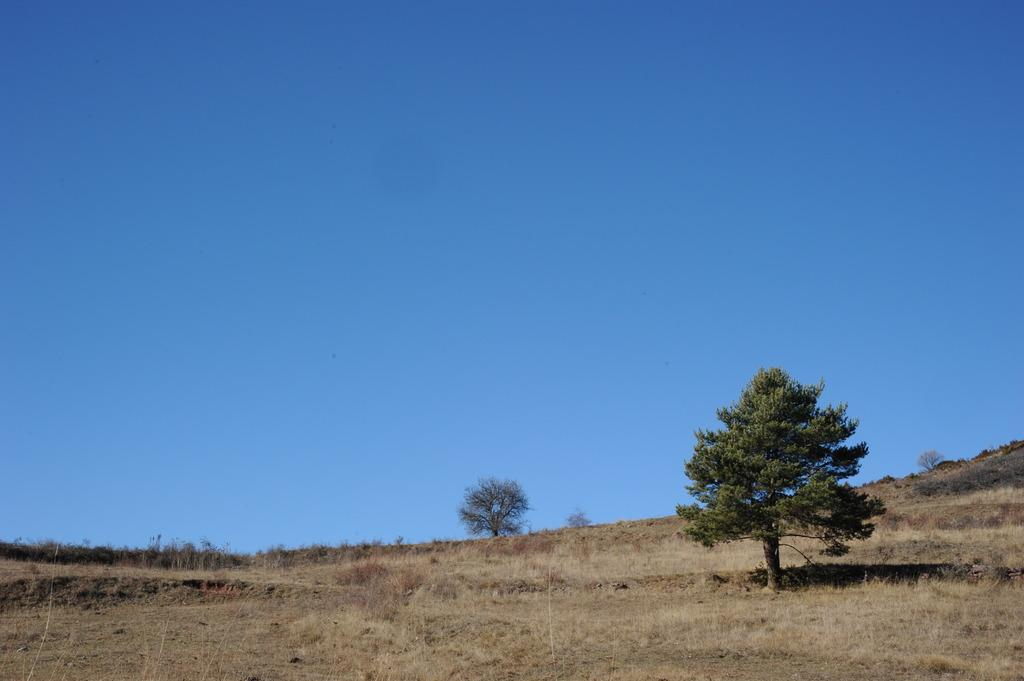Where was the image taken? The image was clicked outside. What type of vegetation is present on the ground in the image? There is dry grass on the ground. How many trees can be seen in the image? There are two trees in the front. What is visible at the top of the image? The sky is visible at the top of the image. Who is the creator of the dry grass in the image? The image does not provide information about the creator of the dry grass; it is a natural element present in the environment. 